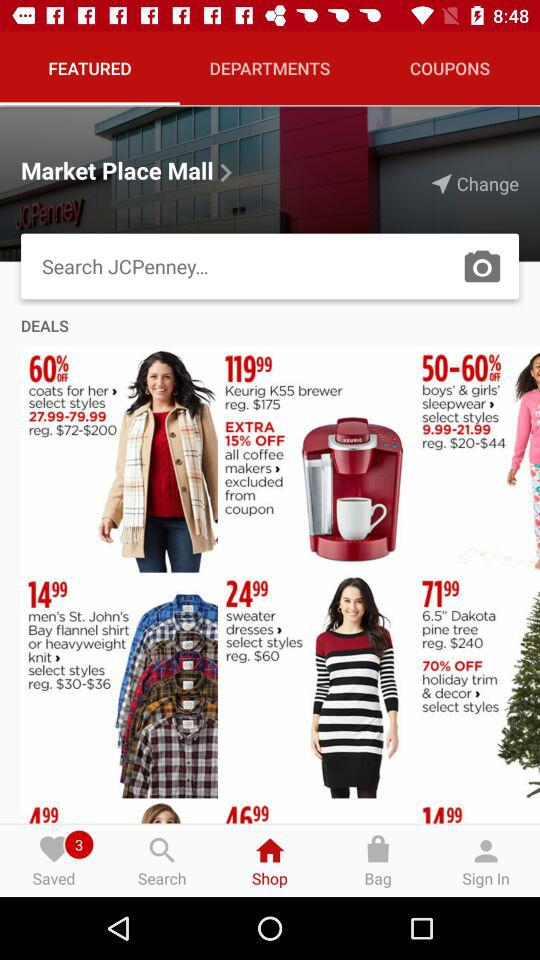How much percent is extra off on all coffee makers? There is an extra 15 percent off on all coffee makers. 